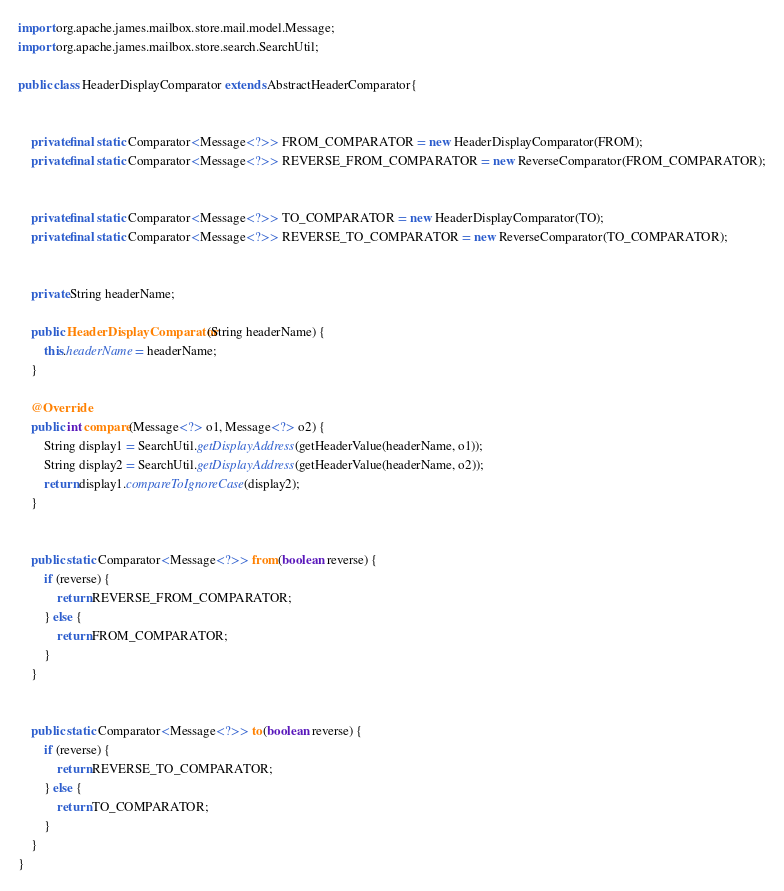Convert code to text. <code><loc_0><loc_0><loc_500><loc_500><_Java_>
import org.apache.james.mailbox.store.mail.model.Message;
import org.apache.james.mailbox.store.search.SearchUtil;

public class HeaderDisplayComparator extends AbstractHeaderComparator{


    private final static Comparator<Message<?>> FROM_COMPARATOR = new HeaderDisplayComparator(FROM);
    private final static Comparator<Message<?>> REVERSE_FROM_COMPARATOR = new ReverseComparator(FROM_COMPARATOR);


    private final static Comparator<Message<?>> TO_COMPARATOR = new HeaderDisplayComparator(TO);
    private final static Comparator<Message<?>> REVERSE_TO_COMPARATOR = new ReverseComparator(TO_COMPARATOR);

    
    private String headerName;

    public HeaderDisplayComparator(String headerName) {
        this.headerName = headerName;
    }
    
    @Override
    public int compare(Message<?> o1, Message<?> o2) {
        String display1 = SearchUtil.getDisplayAddress(getHeaderValue(headerName, o1));
        String display2 = SearchUtil.getDisplayAddress(getHeaderValue(headerName, o2));
        return display1.compareToIgnoreCase(display2);
    }

    
    public static Comparator<Message<?>> from(boolean reverse) {
        if (reverse) {
            return REVERSE_FROM_COMPARATOR;
        } else {
            return FROM_COMPARATOR;
        }
    }

    
    public static Comparator<Message<?>> to(boolean reverse) {
        if (reverse) {
            return REVERSE_TO_COMPARATOR;
        } else {
            return TO_COMPARATOR;
        }
    }
}
</code> 